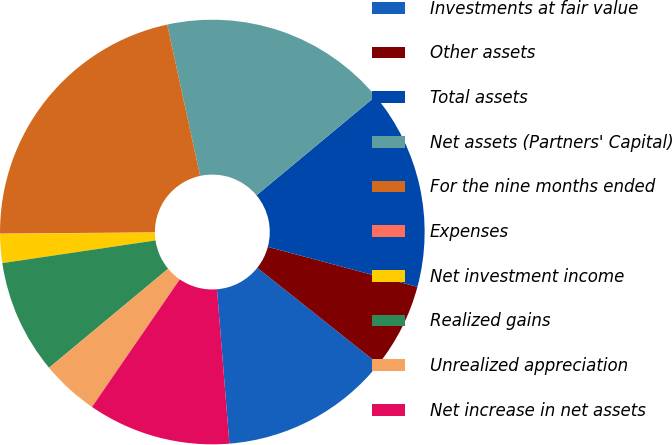Convert chart to OTSL. <chart><loc_0><loc_0><loc_500><loc_500><pie_chart><fcel>Investments at fair value<fcel>Other assets<fcel>Total assets<fcel>Net assets (Partners' Capital)<fcel>For the nine months ended<fcel>Expenses<fcel>Net investment income<fcel>Realized gains<fcel>Unrealized appreciation<fcel>Net increase in net assets<nl><fcel>13.03%<fcel>6.53%<fcel>15.2%<fcel>17.37%<fcel>21.7%<fcel>0.03%<fcel>2.2%<fcel>8.7%<fcel>4.37%<fcel>10.87%<nl></chart> 